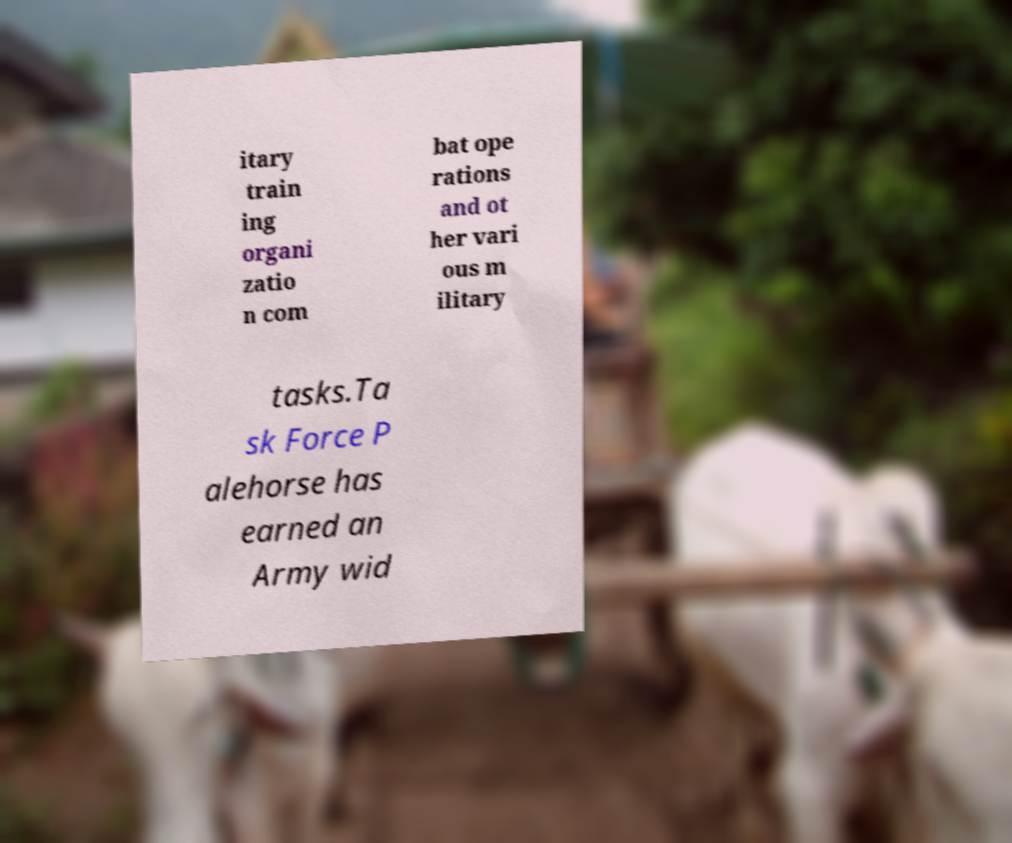Can you accurately transcribe the text from the provided image for me? itary train ing organi zatio n com bat ope rations and ot her vari ous m ilitary tasks.Ta sk Force P alehorse has earned an Army wid 